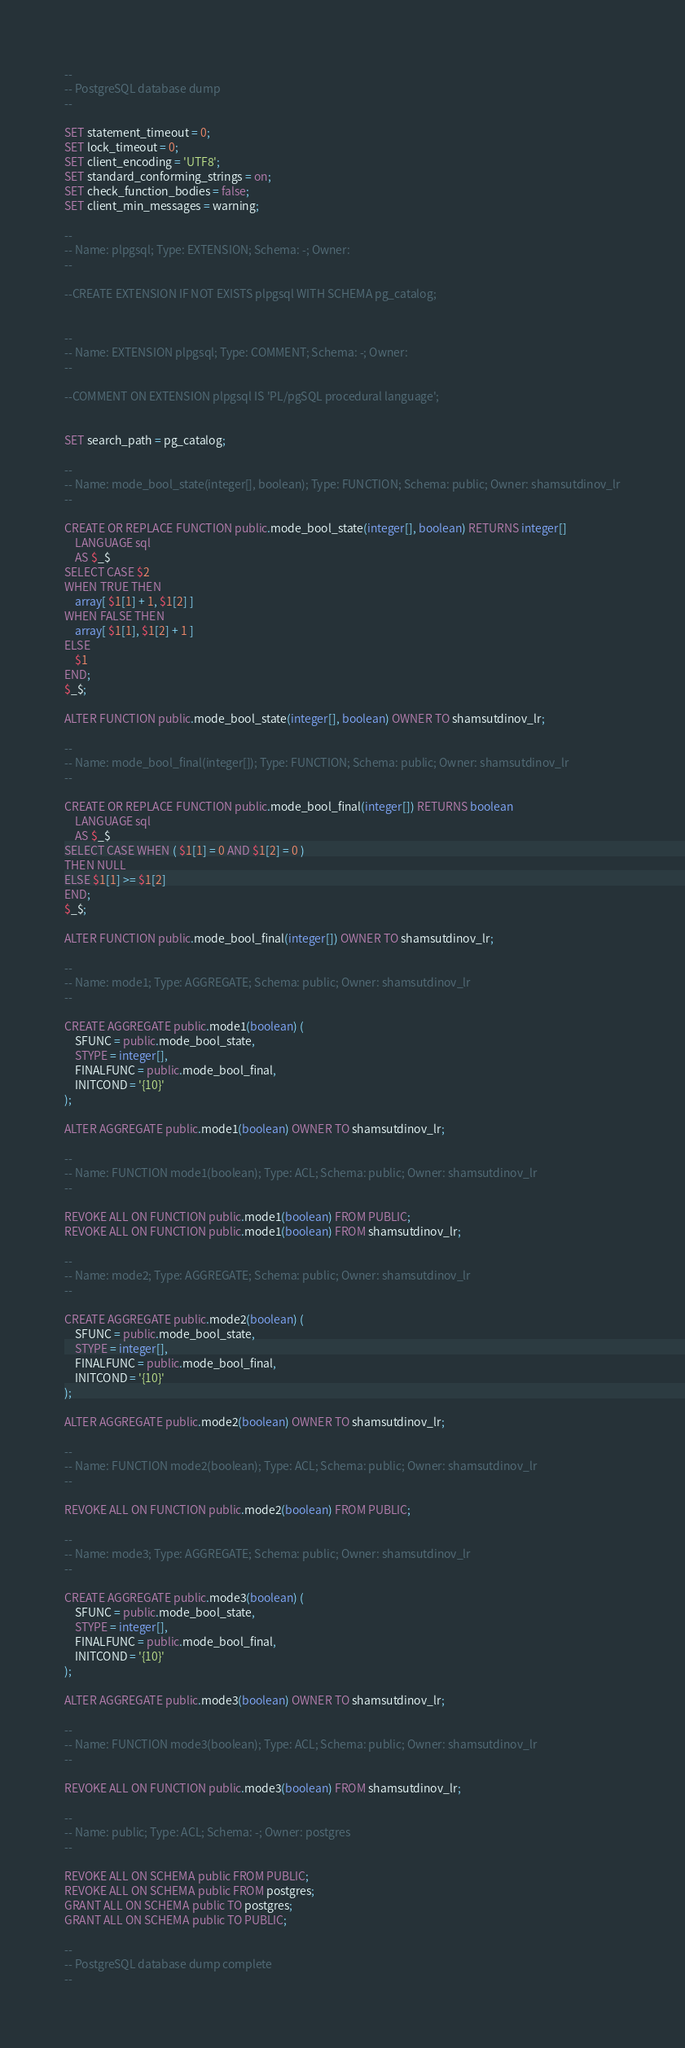Convert code to text. <code><loc_0><loc_0><loc_500><loc_500><_SQL_>--
-- PostgreSQL database dump
--

SET statement_timeout = 0;
SET lock_timeout = 0;
SET client_encoding = 'UTF8';
SET standard_conforming_strings = on;
SET check_function_bodies = false;
SET client_min_messages = warning;

--
-- Name: plpgsql; Type: EXTENSION; Schema: -; Owner: 
--

--CREATE EXTENSION IF NOT EXISTS plpgsql WITH SCHEMA pg_catalog;


--
-- Name: EXTENSION plpgsql; Type: COMMENT; Schema: -; Owner: 
--

--COMMENT ON EXTENSION plpgsql IS 'PL/pgSQL procedural language';


SET search_path = pg_catalog;

--
-- Name: mode_bool_state(integer[], boolean); Type: FUNCTION; Schema: public; Owner: shamsutdinov_lr
--

CREATE OR REPLACE FUNCTION public.mode_bool_state(integer[], boolean) RETURNS integer[]
    LANGUAGE sql
    AS $_$
SELECT CASE $2
WHEN TRUE THEN
    array[ $1[1] + 1, $1[2] ]
WHEN FALSE THEN
    array[ $1[1], $1[2] + 1 ]
ELSE
    $1
END;
$_$;

ALTER FUNCTION public.mode_bool_state(integer[], boolean) OWNER TO shamsutdinov_lr;

--
-- Name: mode_bool_final(integer[]); Type: FUNCTION; Schema: public; Owner: shamsutdinov_lr
--

CREATE OR REPLACE FUNCTION public.mode_bool_final(integer[]) RETURNS boolean
    LANGUAGE sql
    AS $_$
SELECT CASE WHEN ( $1[1] = 0 AND $1[2] = 0 )
THEN NULL
ELSE $1[1] >= $1[2]
END;
$_$;

ALTER FUNCTION public.mode_bool_final(integer[]) OWNER TO shamsutdinov_lr;

--
-- Name: mode1; Type: AGGREGATE; Schema: public; Owner: shamsutdinov_lr
--

CREATE AGGREGATE public.mode1(boolean) (
    SFUNC = public.mode_bool_state,
    STYPE = integer[],
    FINALFUNC = public.mode_bool_final,
    INITCOND = '{10}'
);

ALTER AGGREGATE public.mode1(boolean) OWNER TO shamsutdinov_lr;

--
-- Name: FUNCTION mode1(boolean); Type: ACL; Schema: public; Owner: shamsutdinov_lr
--

REVOKE ALL ON FUNCTION public.mode1(boolean) FROM PUBLIC;
REVOKE ALL ON FUNCTION public.mode1(boolean) FROM shamsutdinov_lr;

--
-- Name: mode2; Type: AGGREGATE; Schema: public; Owner: shamsutdinov_lr
--

CREATE AGGREGATE public.mode2(boolean) (
    SFUNC = public.mode_bool_state,
    STYPE = integer[],
    FINALFUNC = public.mode_bool_final,
    INITCOND = '{10}'
);

ALTER AGGREGATE public.mode2(boolean) OWNER TO shamsutdinov_lr;

--
-- Name: FUNCTION mode2(boolean); Type: ACL; Schema: public; Owner: shamsutdinov_lr
--

REVOKE ALL ON FUNCTION public.mode2(boolean) FROM PUBLIC;

--
-- Name: mode3; Type: AGGREGATE; Schema: public; Owner: shamsutdinov_lr
--

CREATE AGGREGATE public.mode3(boolean) (
    SFUNC = public.mode_bool_state,
    STYPE = integer[],
    FINALFUNC = public.mode_bool_final,
    INITCOND = '{10}'
);

ALTER AGGREGATE public.mode3(boolean) OWNER TO shamsutdinov_lr;

--
-- Name: FUNCTION mode3(boolean); Type: ACL; Schema: public; Owner: shamsutdinov_lr
--

REVOKE ALL ON FUNCTION public.mode3(boolean) FROM shamsutdinov_lr;

--
-- Name: public; Type: ACL; Schema: -; Owner: postgres
--

REVOKE ALL ON SCHEMA public FROM PUBLIC;
REVOKE ALL ON SCHEMA public FROM postgres;
GRANT ALL ON SCHEMA public TO postgres;
GRANT ALL ON SCHEMA public TO PUBLIC;

--
-- PostgreSQL database dump complete
--

</code> 